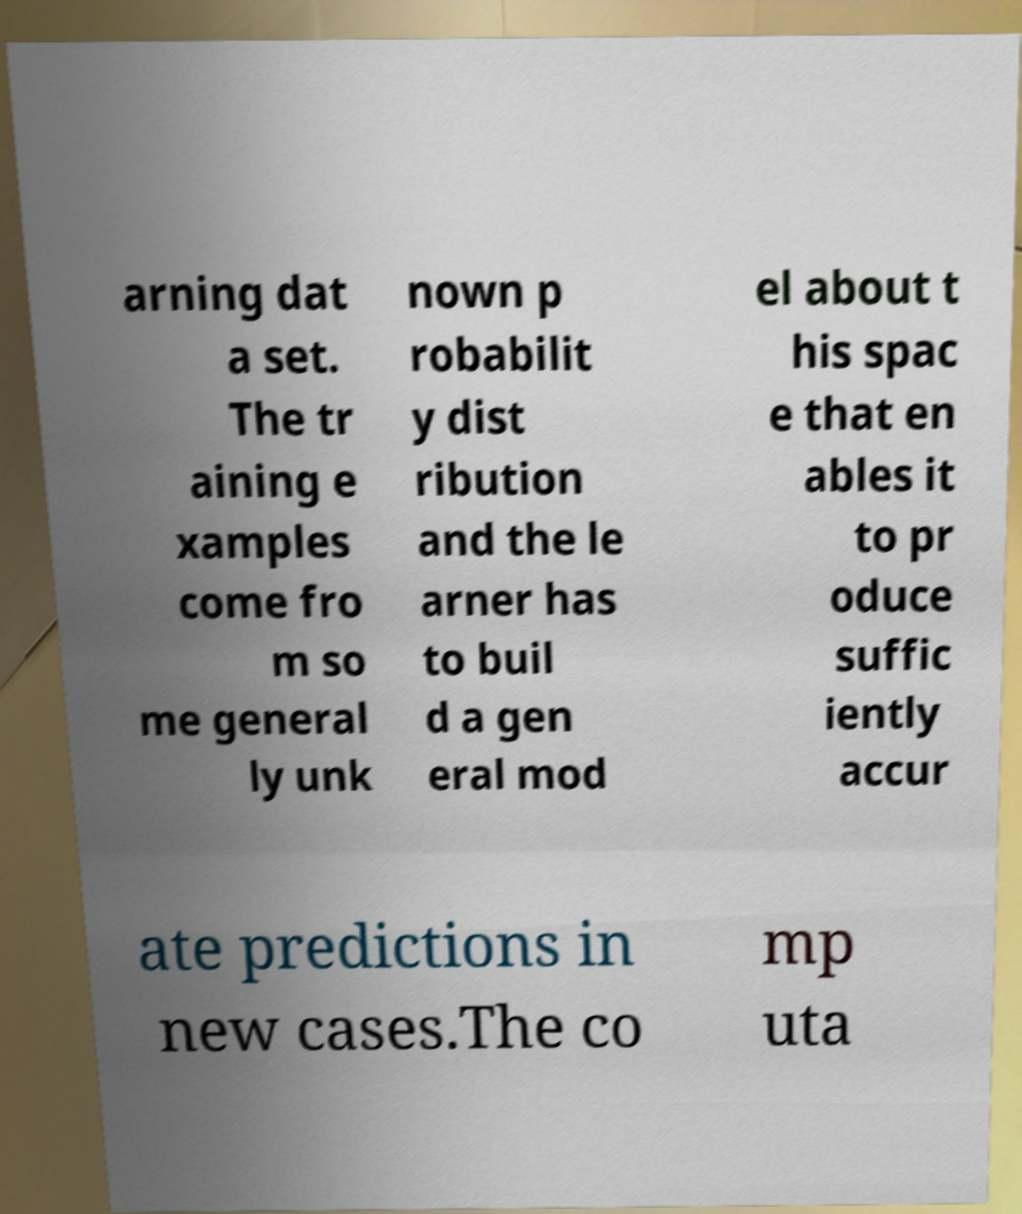Can you accurately transcribe the text from the provided image for me? arning dat a set. The tr aining e xamples come fro m so me general ly unk nown p robabilit y dist ribution and the le arner has to buil d a gen eral mod el about t his spac e that en ables it to pr oduce suffic iently accur ate predictions in new cases.The co mp uta 